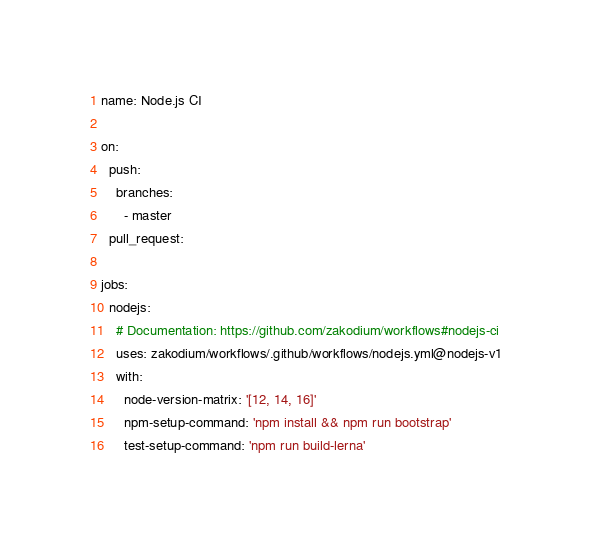<code> <loc_0><loc_0><loc_500><loc_500><_YAML_>name: Node.js CI

on:
  push:
    branches:
      - master
  pull_request:

jobs:
  nodejs:
    # Documentation: https://github.com/zakodium/workflows#nodejs-ci
    uses: zakodium/workflows/.github/workflows/nodejs.yml@nodejs-v1
    with:
      node-version-matrix: '[12, 14, 16]'
      npm-setup-command: 'npm install && npm run bootstrap'
      test-setup-command: 'npm run build-lerna'
</code> 